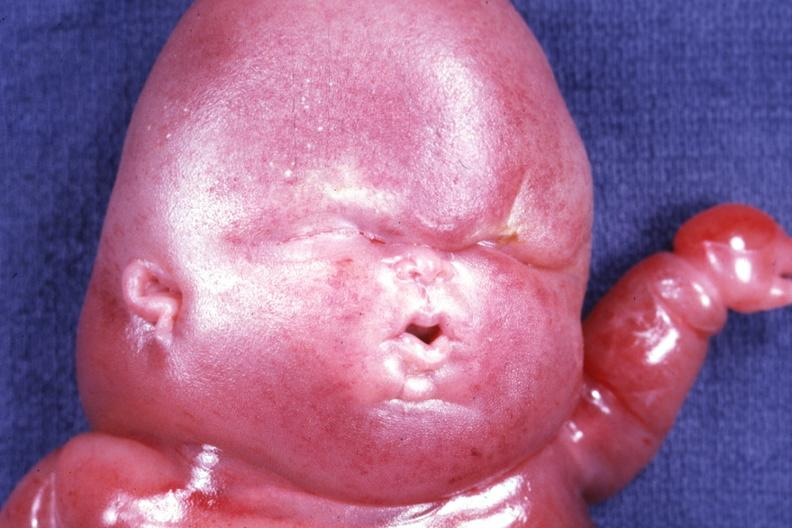what is present?
Answer the question using a single word or phrase. Lymphangiomatosis 